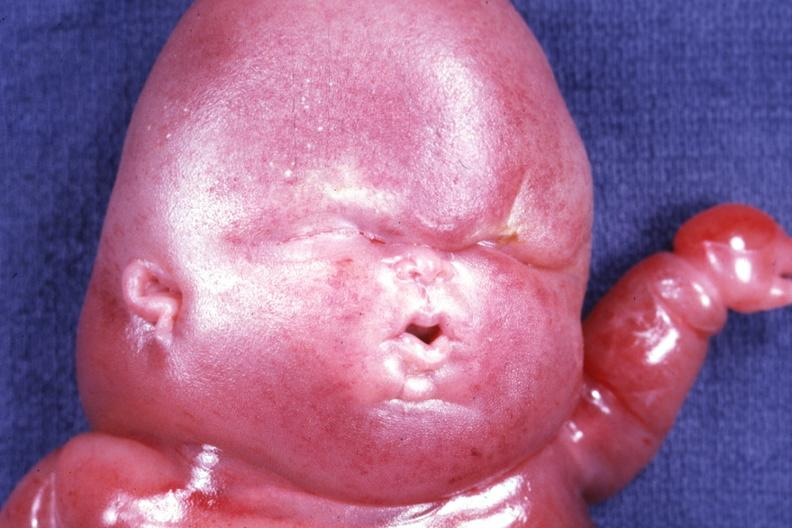what is present?
Answer the question using a single word or phrase. Lymphangiomatosis 